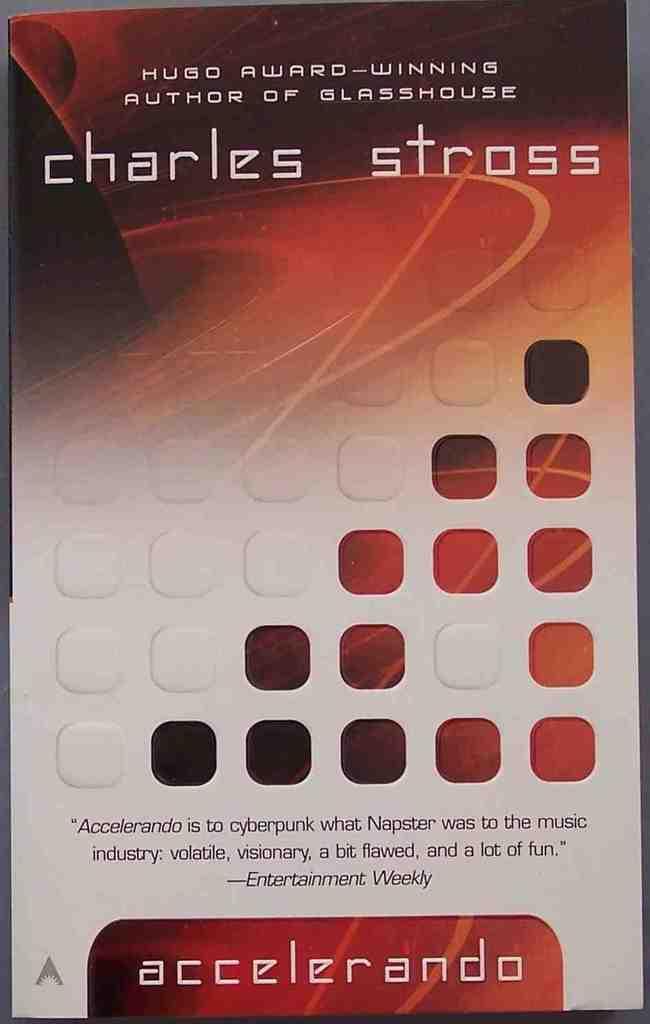Could you give a brief overview of what you see in this image? In this picture, it looks like a pamphlet and on the pamphlet there are words. 